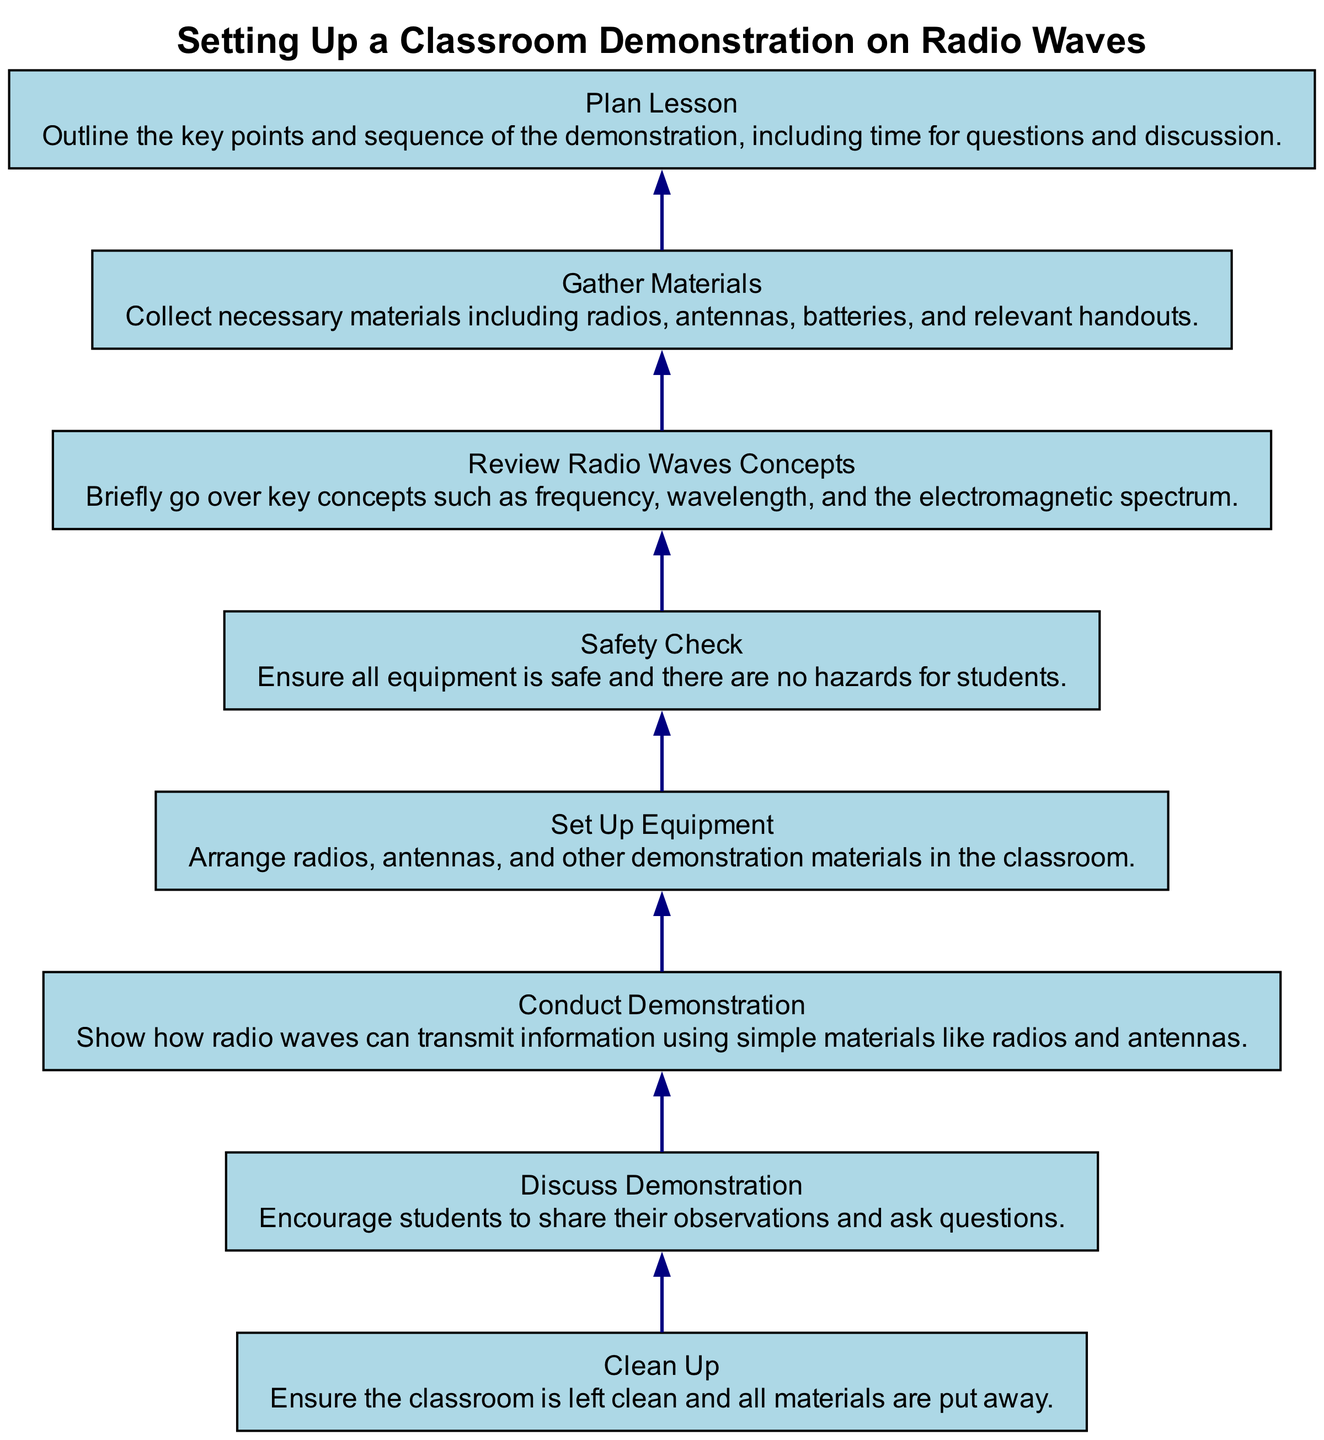What is the first step in the diagram? The first step in the flow chart is "Plan Lesson," which is the bottom node. This means that planning the lesson occurs before other actions are taken to set up the demonstration.
Answer: Plan Lesson How many steps are there in total? By counting each of the nodes in the flow chart, we find there are eight distinct steps.
Answer: 8 What follows the "Gather Materials" step? The "Gather Materials" node is followed directly by the "Plan Lesson" node in the flow chart, indicating that after gathering materials, the next step is planning the lesson.
Answer: Plan Lesson What is the relationship between "Conduct Demonstration" and "Discuss Demonstration"? "Conduct Demonstration" is followed by "Discuss Demonstration" in the flow of the chart, meaning that after the demonstration is conducted, the class will discuss it.
Answer: Conduct Demonstration → Discuss Demonstration Which step comes right before "Clean Up"? The "Discuss Demonstration" step comes right before "Clean Up." This indicates that discussion with students occurs before cleaning up the classroom.
Answer: Discuss Demonstration In which step do you ensure safety? The safety check is done in the "Safety Check" step. This indicates that ensuring safety is a distinct and important phase in the preparation process.
Answer: Safety Check What materials are needed before setting up the equipment? The "Gather Materials" step indicates that materials like radios, antennas, batteries, and handouts are collected before the equipment setup.
Answer: Gather Materials What key concepts are reviewed right before the demonstration? The "Review Radio Waves Concepts" step occurs directly before the "Conduct Demonstration" step, indicating that key concepts are briefly reviewed before demonstrating radio waves.
Answer: Review Radio Waves Concepts 